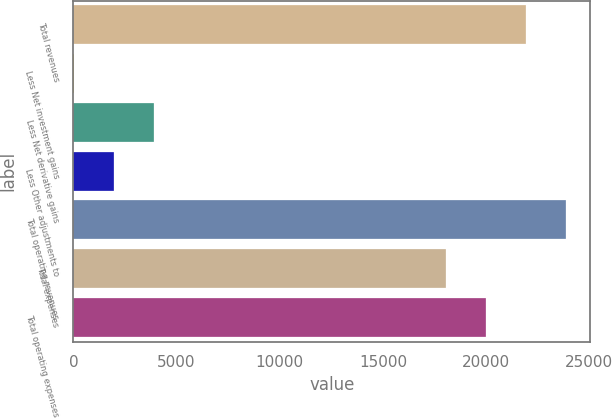Convert chart to OTSL. <chart><loc_0><loc_0><loc_500><loc_500><bar_chart><fcel>Total revenues<fcel>Less Net investment gains<fcel>Less Net derivative gains<fcel>Less Other adjustments to<fcel>Total operating revenues<fcel>Total expenses<fcel>Total operating expenses<nl><fcel>21919.8<fcel>33<fcel>3915.8<fcel>1974.4<fcel>23861.2<fcel>18037<fcel>19978.4<nl></chart> 